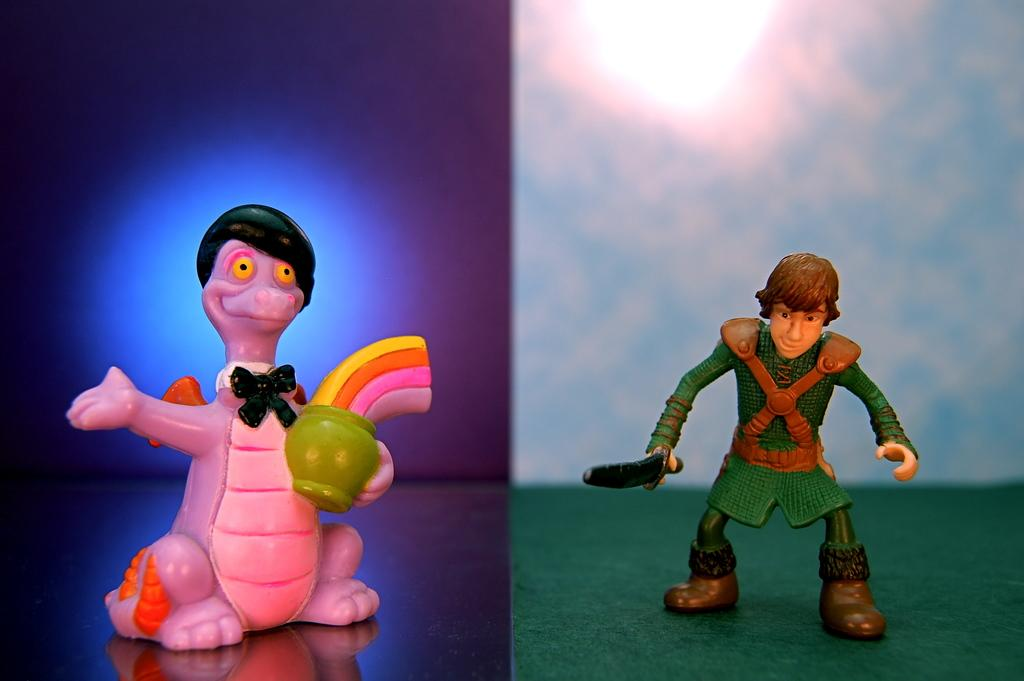How many toys can be seen in the image? There are two toys in the image. What type of instrument is being played by the flame in the image? There is no flame or instrument present in the image; it only features two toys. 